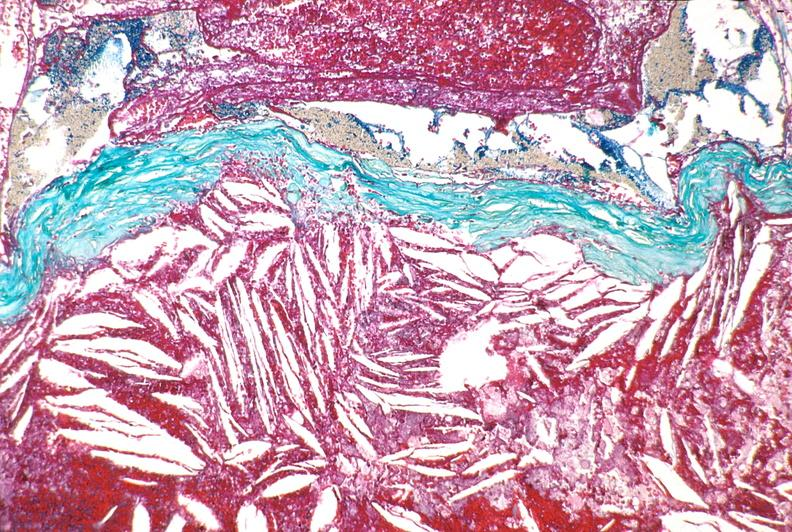what is present?
Answer the question using a single word or phrase. Vasculature 